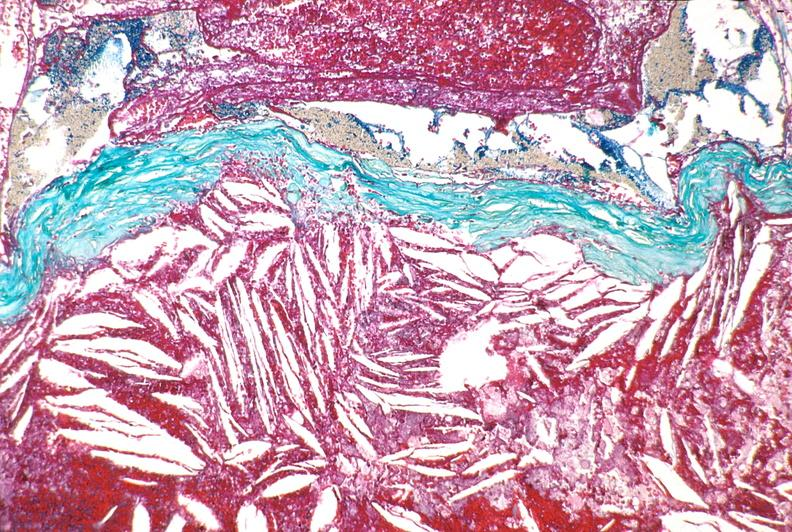what is present?
Answer the question using a single word or phrase. Vasculature 